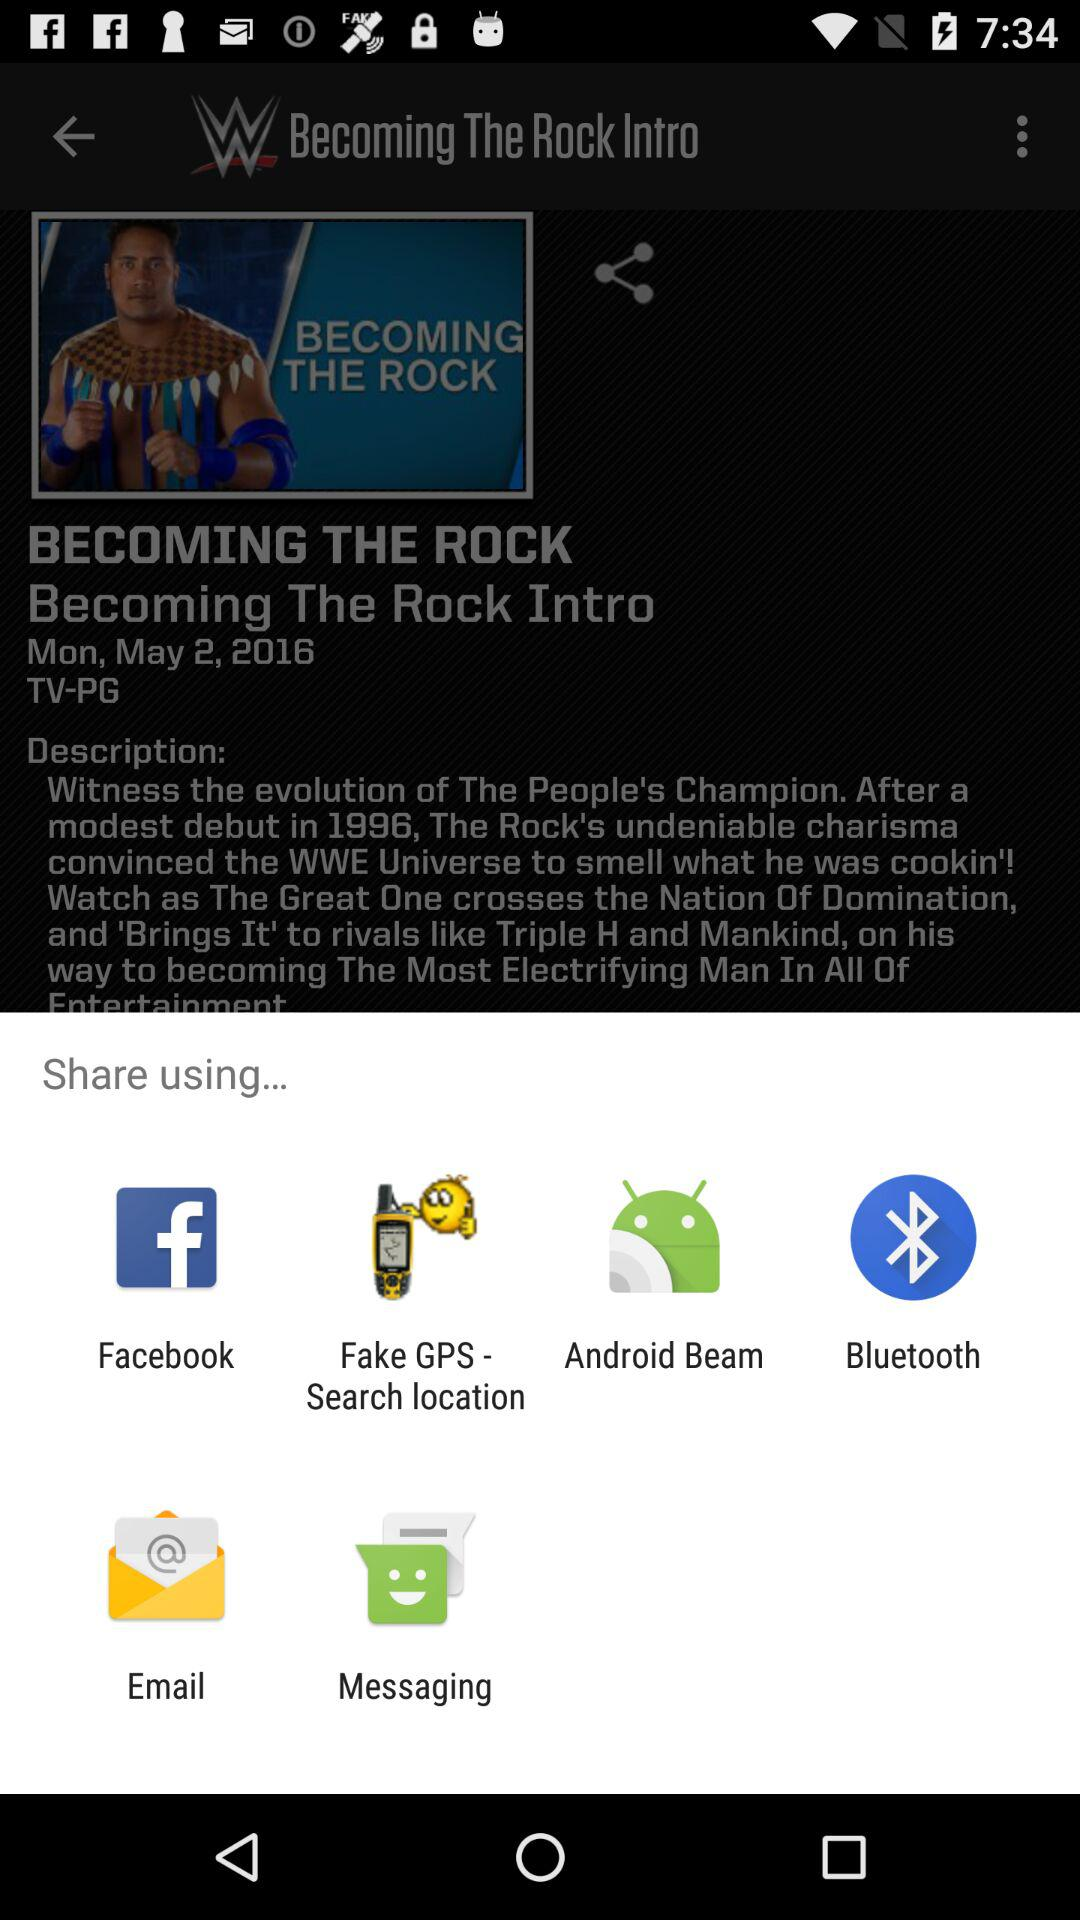Which applications can we use to share? The applications are "Facebook", "Fake GPS - Search location", "Android Beam", "Bluetooth", "Email" and "Messaging". 